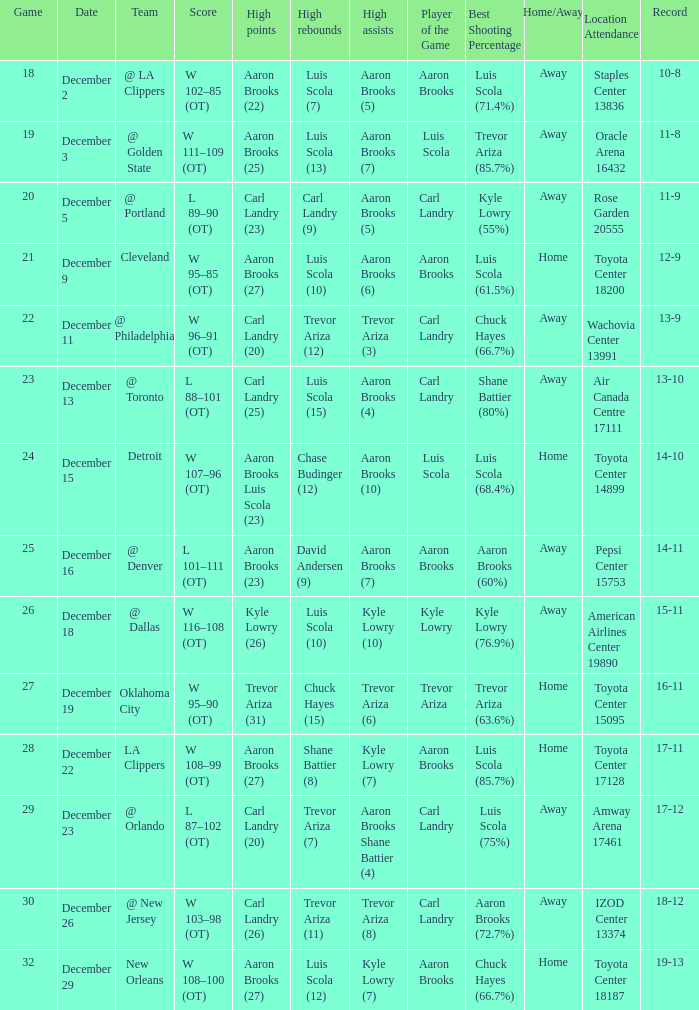Where was the game in which Carl Landry (25) did the most high points played? Air Canada Centre 17111. Would you mind parsing the complete table? {'header': ['Game', 'Date', 'Team', 'Score', 'High points', 'High rebounds', 'High assists', 'Player of the Game', 'Best Shooting Percentage', 'Home/Away', 'Location Attendance', 'Record'], 'rows': [['18', 'December 2', '@ LA Clippers', 'W 102–85 (OT)', 'Aaron Brooks (22)', 'Luis Scola (7)', 'Aaron Brooks (5)', 'Aaron Brooks', 'Luis Scola (71.4%)', 'Away', 'Staples Center 13836', '10-8'], ['19', 'December 3', '@ Golden State', 'W 111–109 (OT)', 'Aaron Brooks (25)', 'Luis Scola (13)', 'Aaron Brooks (7)', 'Luis Scola', 'Trevor Ariza (85.7%)', 'Away', 'Oracle Arena 16432', '11-8'], ['20', 'December 5', '@ Portland', 'L 89–90 (OT)', 'Carl Landry (23)', 'Carl Landry (9)', 'Aaron Brooks (5)', 'Carl Landry', 'Kyle Lowry (55%)', 'Away', 'Rose Garden 20555', '11-9'], ['21', 'December 9', 'Cleveland', 'W 95–85 (OT)', 'Aaron Brooks (27)', 'Luis Scola (10)', 'Aaron Brooks (6)', 'Aaron Brooks', 'Luis Scola (61.5%)', 'Home', 'Toyota Center 18200', '12-9'], ['22', 'December 11', '@ Philadelphia', 'W 96–91 (OT)', 'Carl Landry (20)', 'Trevor Ariza (12)', 'Trevor Ariza (3)', 'Carl Landry', 'Chuck Hayes (66.7%)', 'Away', 'Wachovia Center 13991', '13-9'], ['23', 'December 13', '@ Toronto', 'L 88–101 (OT)', 'Carl Landry (25)', 'Luis Scola (15)', 'Aaron Brooks (4)', 'Carl Landry', 'Shane Battier (80%)', 'Away', 'Air Canada Centre 17111', '13-10'], ['24', 'December 15', 'Detroit', 'W 107–96 (OT)', 'Aaron Brooks Luis Scola (23)', 'Chase Budinger (12)', 'Aaron Brooks (10)', 'Luis Scola', 'Luis Scola (68.4%)', 'Home', 'Toyota Center 14899', '14-10'], ['25', 'December 16', '@ Denver', 'L 101–111 (OT)', 'Aaron Brooks (23)', 'David Andersen (9)', 'Aaron Brooks (7)', 'Aaron Brooks', 'Aaron Brooks (60%)', 'Away', 'Pepsi Center 15753', '14-11'], ['26', 'December 18', '@ Dallas', 'W 116–108 (OT)', 'Kyle Lowry (26)', 'Luis Scola (10)', 'Kyle Lowry (10)', 'Kyle Lowry', 'Kyle Lowry (76.9%)', 'Away', 'American Airlines Center 19890', '15-11'], ['27', 'December 19', 'Oklahoma City', 'W 95–90 (OT)', 'Trevor Ariza (31)', 'Chuck Hayes (15)', 'Trevor Ariza (6)', 'Trevor Ariza', 'Trevor Ariza (63.6%)', 'Home', 'Toyota Center 15095', '16-11'], ['28', 'December 22', 'LA Clippers', 'W 108–99 (OT)', 'Aaron Brooks (27)', 'Shane Battier (8)', 'Kyle Lowry (7)', 'Aaron Brooks', 'Luis Scola (85.7%)', 'Home', 'Toyota Center 17128', '17-11'], ['29', 'December 23', '@ Orlando', 'L 87–102 (OT)', 'Carl Landry (20)', 'Trevor Ariza (7)', 'Aaron Brooks Shane Battier (4)', 'Carl Landry', 'Luis Scola (75%)', 'Away', 'Amway Arena 17461', '17-12'], ['30', 'December 26', '@ New Jersey', 'W 103–98 (OT)', 'Carl Landry (26)', 'Trevor Ariza (11)', 'Trevor Ariza (8)', 'Carl Landry', 'Aaron Brooks (72.7%)', 'Away', 'IZOD Center 13374', '18-12'], ['32', 'December 29', 'New Orleans', 'W 108–100 (OT)', 'Aaron Brooks (27)', 'Luis Scola (12)', 'Kyle Lowry (7)', 'Aaron Brooks', 'Chuck Hayes (66.7%)', 'Home', 'Toyota Center 18187', '19-13']]} 